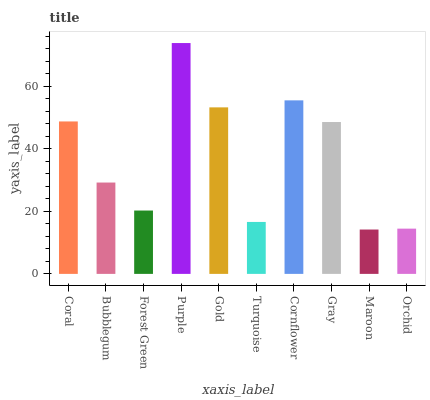Is Maroon the minimum?
Answer yes or no. Yes. Is Purple the maximum?
Answer yes or no. Yes. Is Bubblegum the minimum?
Answer yes or no. No. Is Bubblegum the maximum?
Answer yes or no. No. Is Coral greater than Bubblegum?
Answer yes or no. Yes. Is Bubblegum less than Coral?
Answer yes or no. Yes. Is Bubblegum greater than Coral?
Answer yes or no. No. Is Coral less than Bubblegum?
Answer yes or no. No. Is Gray the high median?
Answer yes or no. Yes. Is Bubblegum the low median?
Answer yes or no. Yes. Is Gold the high median?
Answer yes or no. No. Is Forest Green the low median?
Answer yes or no. No. 